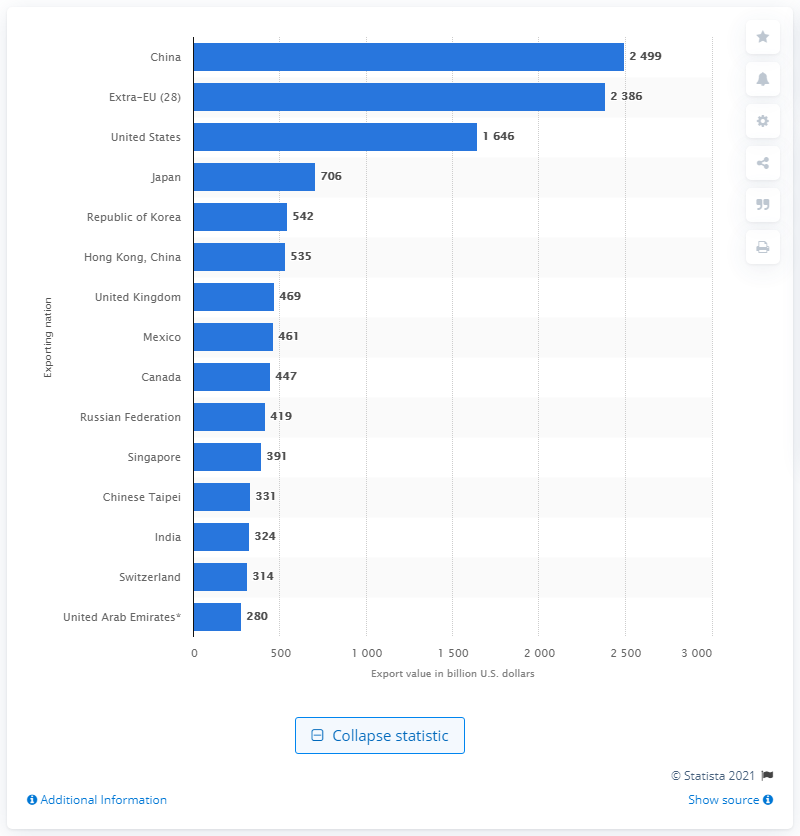Identify some key points in this picture. In 2019, the value of the United States in dollars was 1646. 